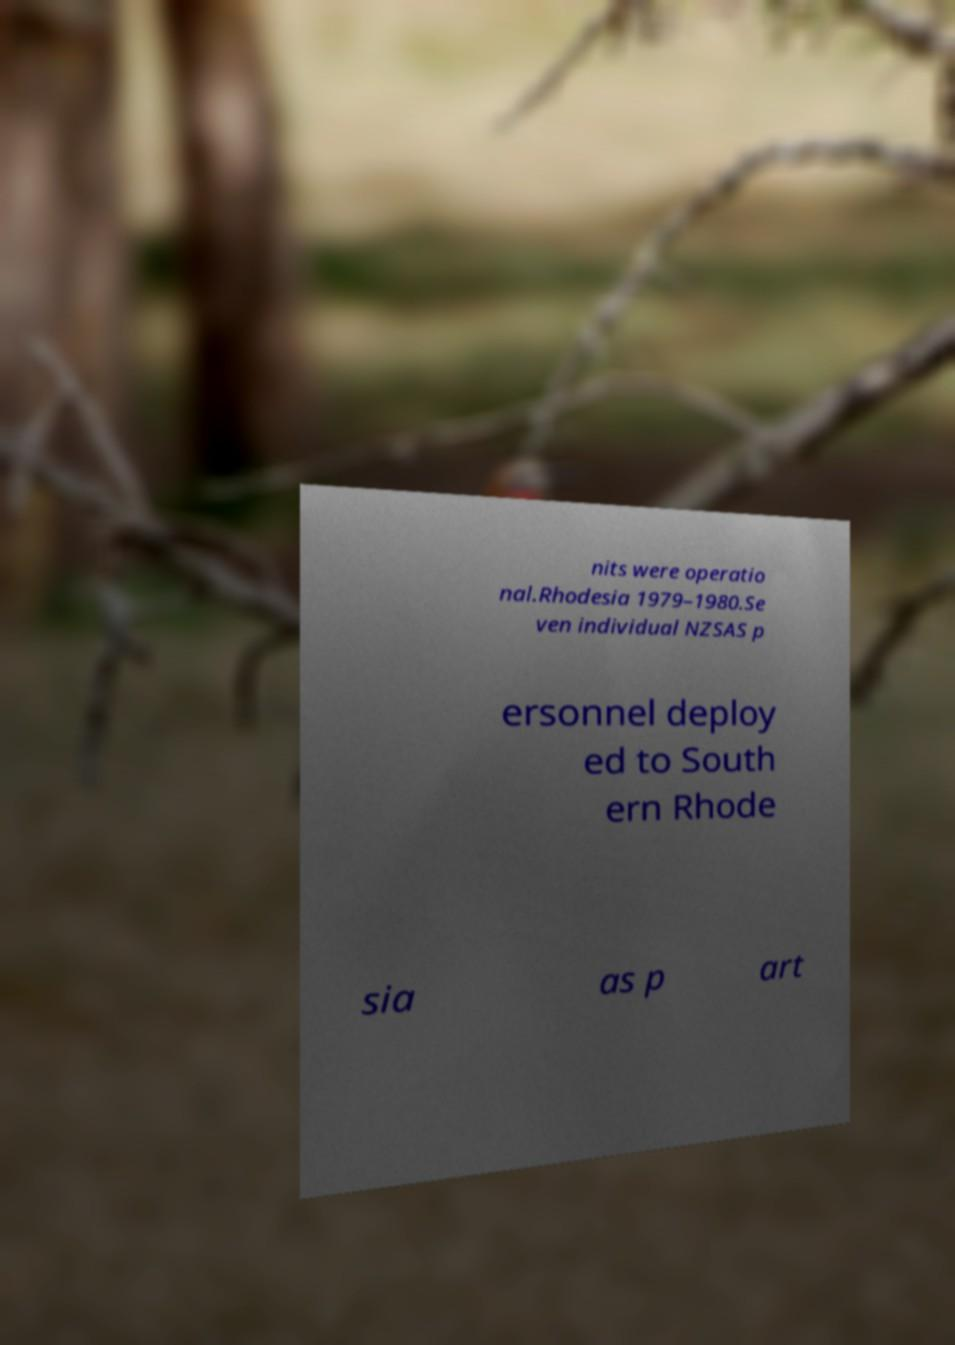Please identify and transcribe the text found in this image. nits were operatio nal.Rhodesia 1979–1980.Se ven individual NZSAS p ersonnel deploy ed to South ern Rhode sia as p art 